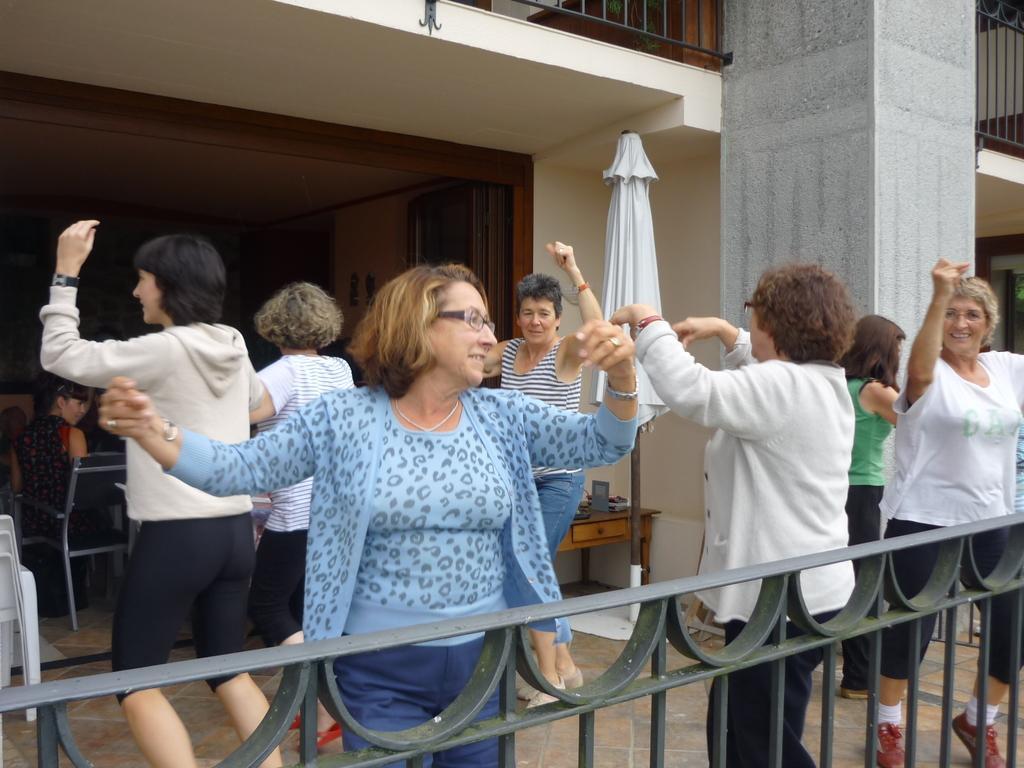Can you describe this image briefly? In the picture we can see some woman are dancing on the floor beside them, we can see a railing and behind them, we can see inside the restaurant with some person sitting on the chair and outside the restaurant we can see an umbrella to the pole and on the top of it we can see another floor with a railing to it and beside it we can see a pillar. 